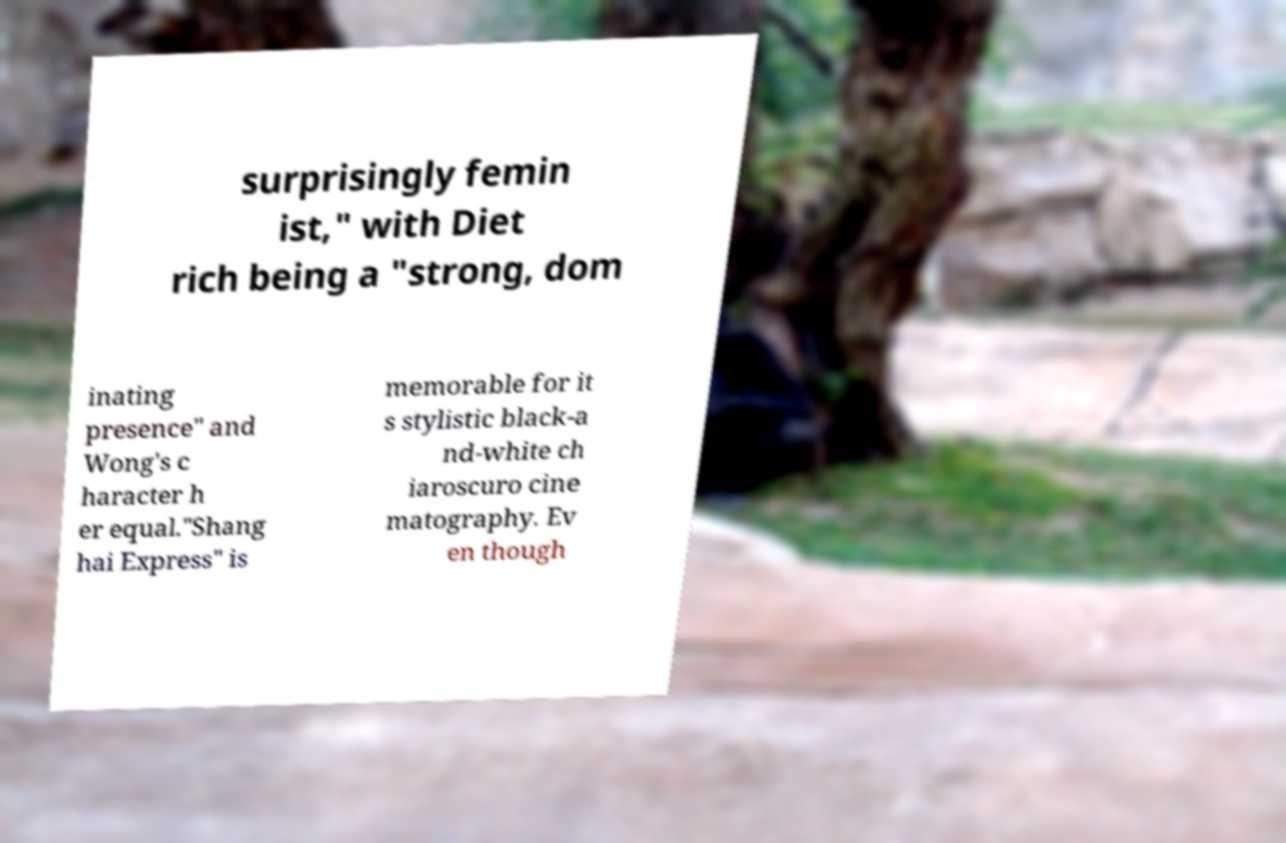Please identify and transcribe the text found in this image. surprisingly femin ist," with Diet rich being a "strong, dom inating presence" and Wong's c haracter h er equal."Shang hai Express" is memorable for it s stylistic black-a nd-white ch iaroscuro cine matography. Ev en though 